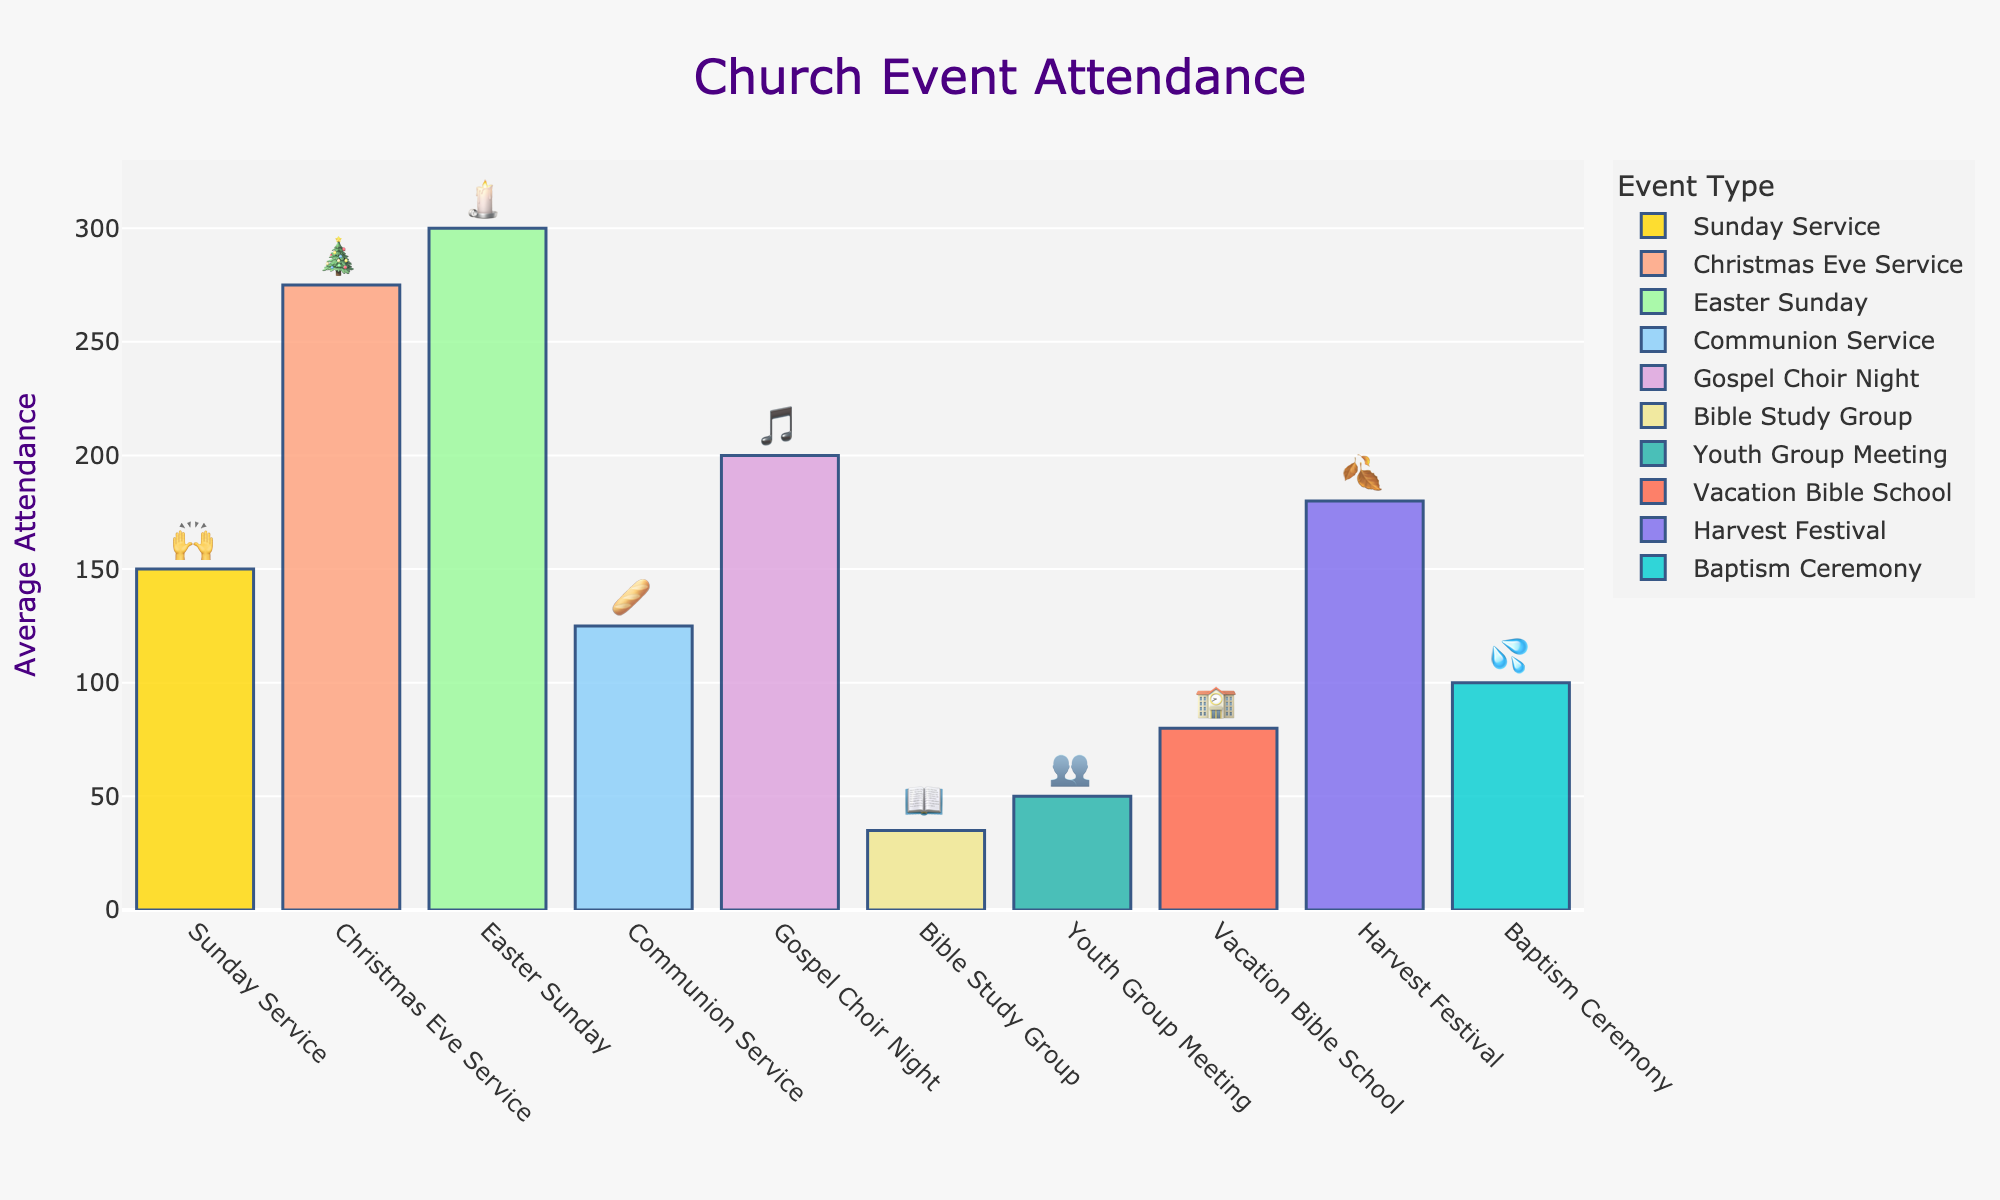What is the title of the chart? The title of the chart is displayed at the top, and it indicates the overall subject of the visual representation.
Answer: Church Event Attendance Which church event has the highest average attendance? To determine the event with the highest attendance, compare the y-values (average attendance) and select the tallest bar.
Answer: Easter Sunday 🕯️ How many events have an average attendance of more than 200 people? Count the number of bars whose height corresponds to a y-value of greater than 200.
Answer: 3 What is the total average attendance for Sunday Service, Communion Service, and Baptism Ceremony combined? Add the average attendance values for these events: Sunday Service (150) + Communion Service (125) + Baptism Ceremony (100) = 375.
Answer: 375 Which event has the closest average attendance to the Gospel Choir Night? Compare the heights of the bars and find the one with an average attendance closest to 200.
Answer: Harvest Festival 🍂 Which event has a lower average attendance, Bible Study Group or Youth Group Meeting? Compare the average attendance values for Bible Study Group (35) and Youth Group Meeting (50).
Answer: Bible Study Group 📖 What is the difference in average attendance between the Christmas Eve Service and the Vacation Bible School? Subtract the average attendance of Vacation Bible School (80) from that of the Christmas Eve Service (275).
Answer: 195 Arrange the events in ascending order of average attendance. List the events starting from the lowest average attendance to the highest by comparing their y-values.
Answer: Bible Study Group 📖, Youth Group Meeting 👥, Vacation Bible School 🏫, Baptism Ceremony 💦, Communion Service 🥖, Sunday Service 🙌, Harvest Festival 🍂, Gospel Choir Night 🎵, Christmas Eve Service 🎄, Easter Sunday 🕯️ What is the average attendance for church services in general, considering Sunday Service, Communion Service, and Easter Sunday? Sum the attendance values of the specified services, then divide by the number of services: (150 + 125 + 300) / 3 = 575 / 3 = 191.67.
Answer: 191.67 What is the median attendance for the given church events? Order the attendance values from lowest to highest: 35, 50, 80, 100, 125, 150, 180, 200, 275, 300. The median attendance is the middle value or the average of two middle values: (125 + 150) / 2 = 137.5.
Answer: 137.5 